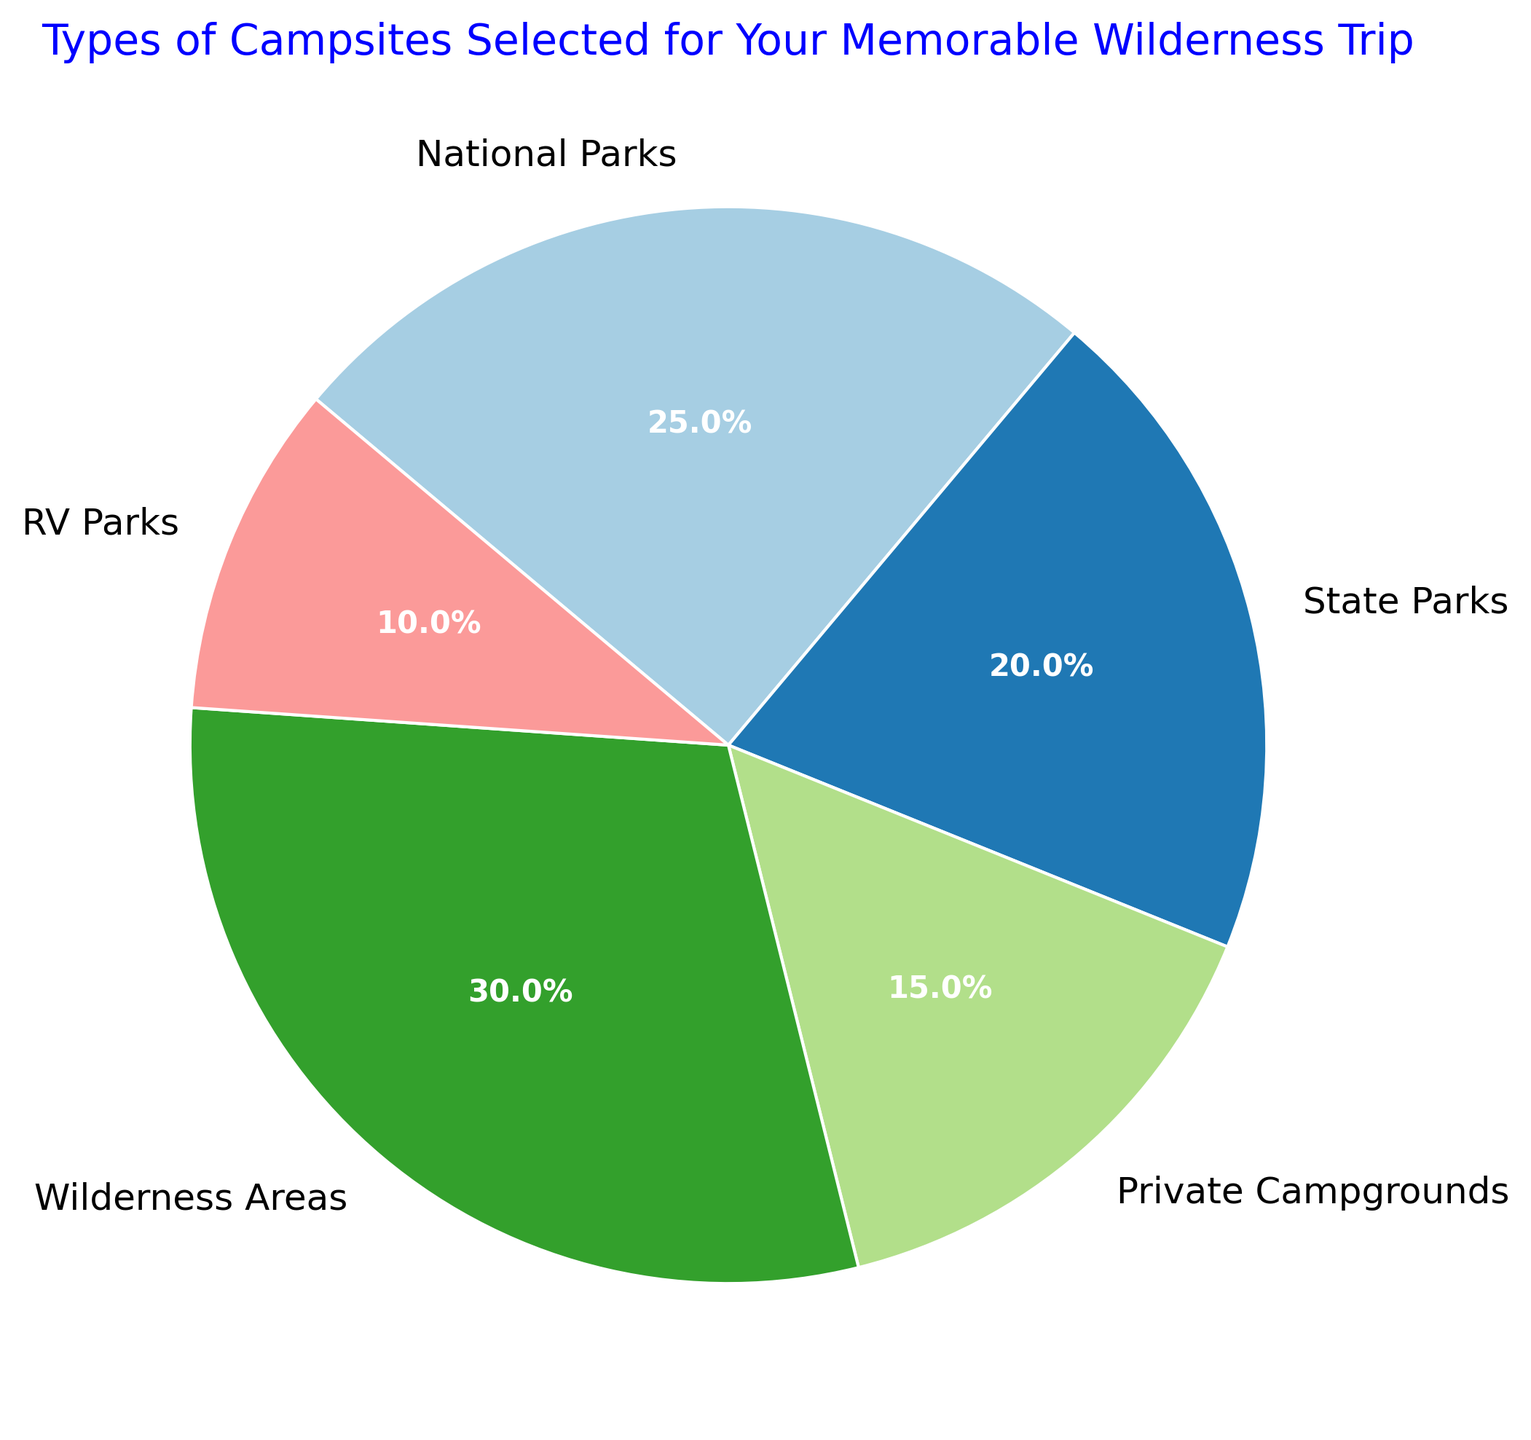What percentage of the pie chart is made up of National Parks and RV Parks combined? To find the combined percentage, add the percentages of National Parks and RV Parks. National Parks is 25% and RV Parks is 10%. So, 25% + 10% = 35%
Answer: 35% Which campsite type has the largest percentage? According to the pie chart, Wilderness Areas have the highest percentage at 30%
Answer: Wilderness Areas What is the difference in percentage between State Parks and Private Campgrounds? From the chart, the percentage for State Parks is 20% and for Private Campgrounds is 15%. The difference is 20% - 15% = 5%
Answer: 5% Are there more campsites selected in State Parks or National Parks? The pie chart shows State Parks at 20% and National Parks at 25%. So, there are more campsites selected in National Parks
Answer: National Parks What's the total percentage of campsites selected that are not Wilderness Areas? Subtract the percentage of Wilderness Areas from 100%. Wilderness Areas are 30%, so 100% - 30% = 70%
Answer: 70% Which two types of campsites together make up 35% of the chart? Summing up percentages, National Parks (25%) and RV Parks (10%) together make up 35%. No other combinations of two types meet this requirement
Answer: National Parks and RV Parks How does the selection percentage of Private Campgrounds compare to the selection percentage of RV Parks? According to the pie chart, Private Campgrounds have a higher percentage (15%) compared to RV Parks (10%)
Answer: Private Campgrounds have a higher percentage Between National Parks and Wilderness Areas, which one has a greater percentage and by how much? The pie chart shows Wilderness Areas at 30% and National Parks at 25%. The difference is 30% - 25% = 5%. Therefore, Wilderness Areas have a greater percentage by 5%
Answer: Wilderness Areas by 5% What's the average percentage of State Parks, Private Campgrounds, and Wilderness Areas? Add up the percentages of State Parks, Private Campgrounds, and Wilderness Areas: 20% + 15% + 30% = 65%. Then, divide by 3: 65% / 3 ≈ 21.67%
Answer: 21.67% 